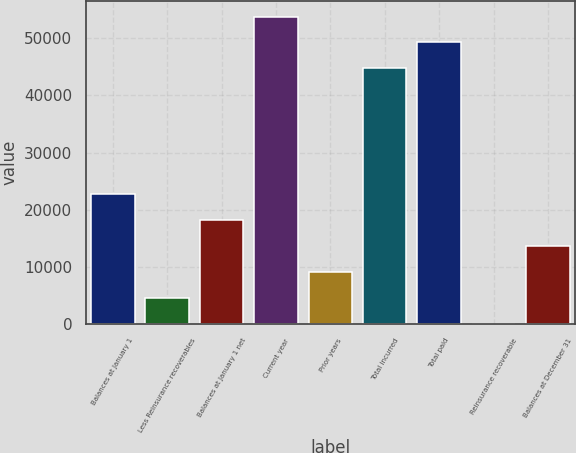<chart> <loc_0><loc_0><loc_500><loc_500><bar_chart><fcel>Balances at January 1<fcel>Less Reinsurance recoverables<fcel>Balances at January 1 net<fcel>Current year<fcel>Prior years<fcel>Total incurred<fcel>Total paid<fcel>Reinsurance recoverable<fcel>Balances at December 31<nl><fcel>22697<fcel>4600.2<fcel>18172.8<fcel>53784.4<fcel>9124.4<fcel>44736<fcel>49260.2<fcel>76<fcel>13648.6<nl></chart> 